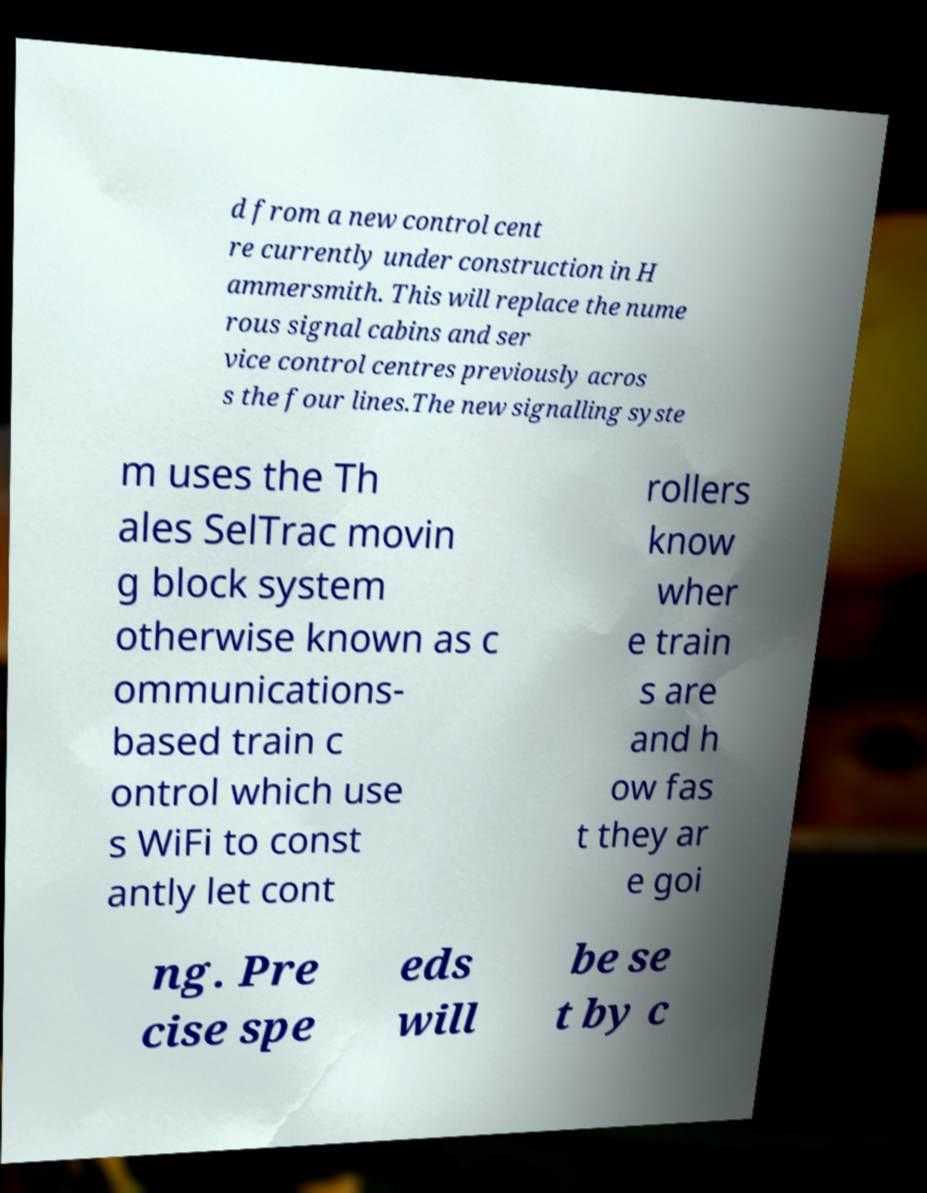For documentation purposes, I need the text within this image transcribed. Could you provide that? d from a new control cent re currently under construction in H ammersmith. This will replace the nume rous signal cabins and ser vice control centres previously acros s the four lines.The new signalling syste m uses the Th ales SelTrac movin g block system otherwise known as c ommunications- based train c ontrol which use s WiFi to const antly let cont rollers know wher e train s are and h ow fas t they ar e goi ng. Pre cise spe eds will be se t by c 